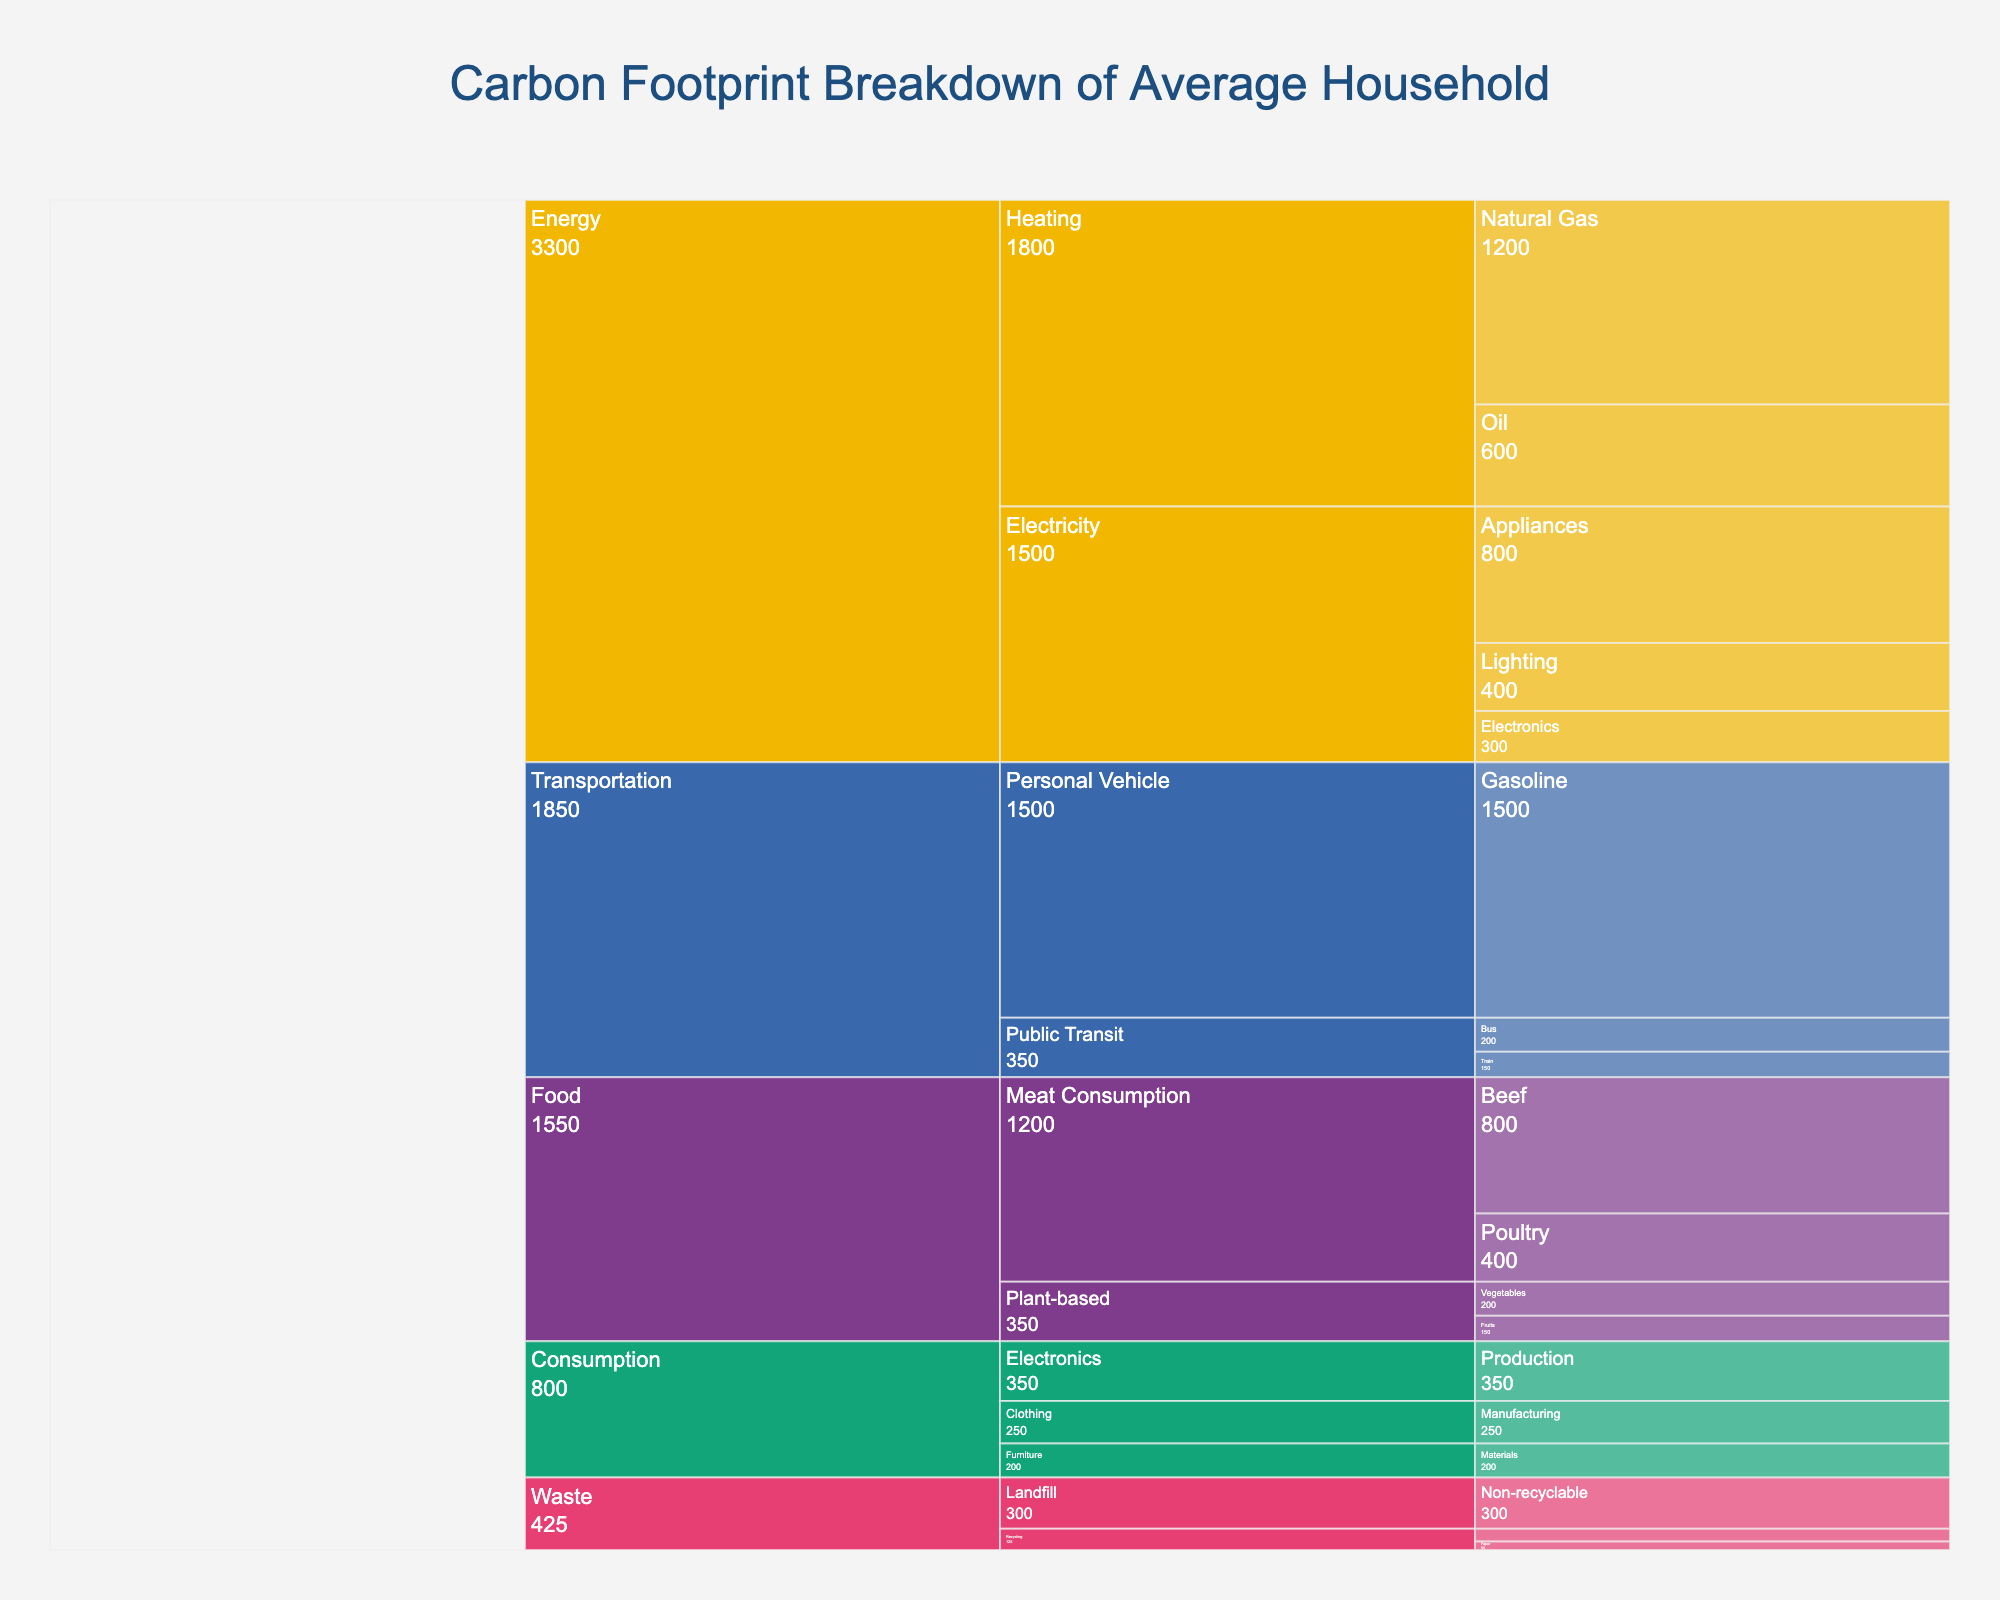What is the title of the figure? The title of the figure is usually displayed prominently at the top. In this chart, it is mentioned as "Carbon Footprint Breakdown of Average Household".
Answer: Carbon Footprint Breakdown of Average Household Which category has the largest overall carbon footprint? To determine this, we need to sum up the values within each main category and compare them. Summing up: Energy (400+800+300+1200+600 = 3300), Transportation (1500+200+150 = 1850), Food (800+400+200+150 = 1550), Waste (300+50+75 = 425), Consumption (250+350+200 = 800). The largest sum is 3300 for Energy.
Answer: Energy What is the total carbon footprint for Heating within the Energy category? Add the values under Heating: Natural Gas (1200) + Oil (600).
Answer: 1800 How does the carbon footprint of Personal Vehicle Gasoline compare to the entire Public Transit category? The carbon footprint of Personal Vehicle Gasoline is 1500. For Public Transit, sum Bus (200) + Train (150). So 1500 vs 350.
Answer: Personal Vehicle Gasoline is larger What is the value for Non-recyclable landfill waste? Find 'Non-recyclable' under 'Landfill' in 'Waste'.
Answer: 300 What is the contribution of Plant-based Food to the overall carbon footprint? Sum the Plant-based sources: Vegetables (200) + Fruits (150).
Answer: 350 Which subcategory within Consumption has the highest carbon footprint? Compare the values under Consumption: Clothing (250), Electronics (350), Furniture (200).
Answer: Electronics Is the carbon footprint for Beef in Meat Consumption higher than that for Poultry? Compare the values for Beef (800) and Poultry (400).
Answer: Yes How do the carbon footprints of Electricity for Appliances and Heating for Natural Gas compare? Compare the values for Appliances (800) and Natural Gas (1200).
Answer: Heating for Natural Gas is higher What is the smallest carbon footprint contribution within the Waste category? Compare within Waste: Non-recyclable (300), Paper (50), Plastics (75).
Answer: Paper 